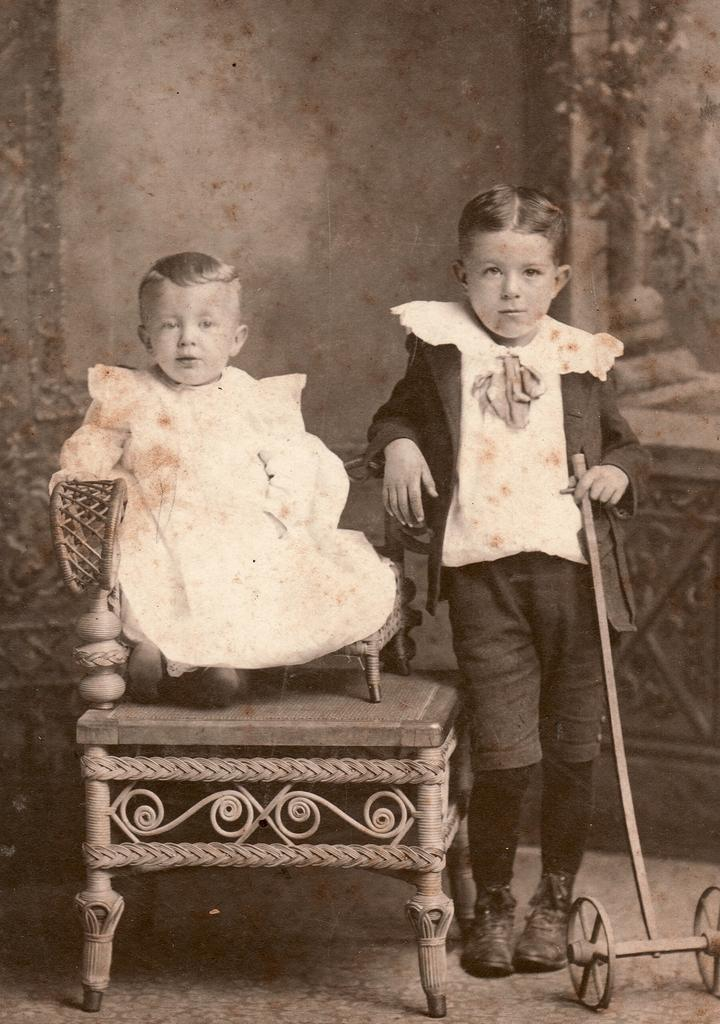What is the color scheme of the image? The image is black and white. Who is present in the image? There are kids in the image. What is the position of one of the kids in the image? One of the kids is sitting on a chair. What is another kid doing in the image? Another kid is holding an object. What type of cat can be seen sleeping on the quilt in the image? There is no cat or quilt present in the image; it features kids in a black and white setting. What flavor of pie is being shared by the kids in the image? There is no pie present in the image; the kids are not shown sharing any food items. 